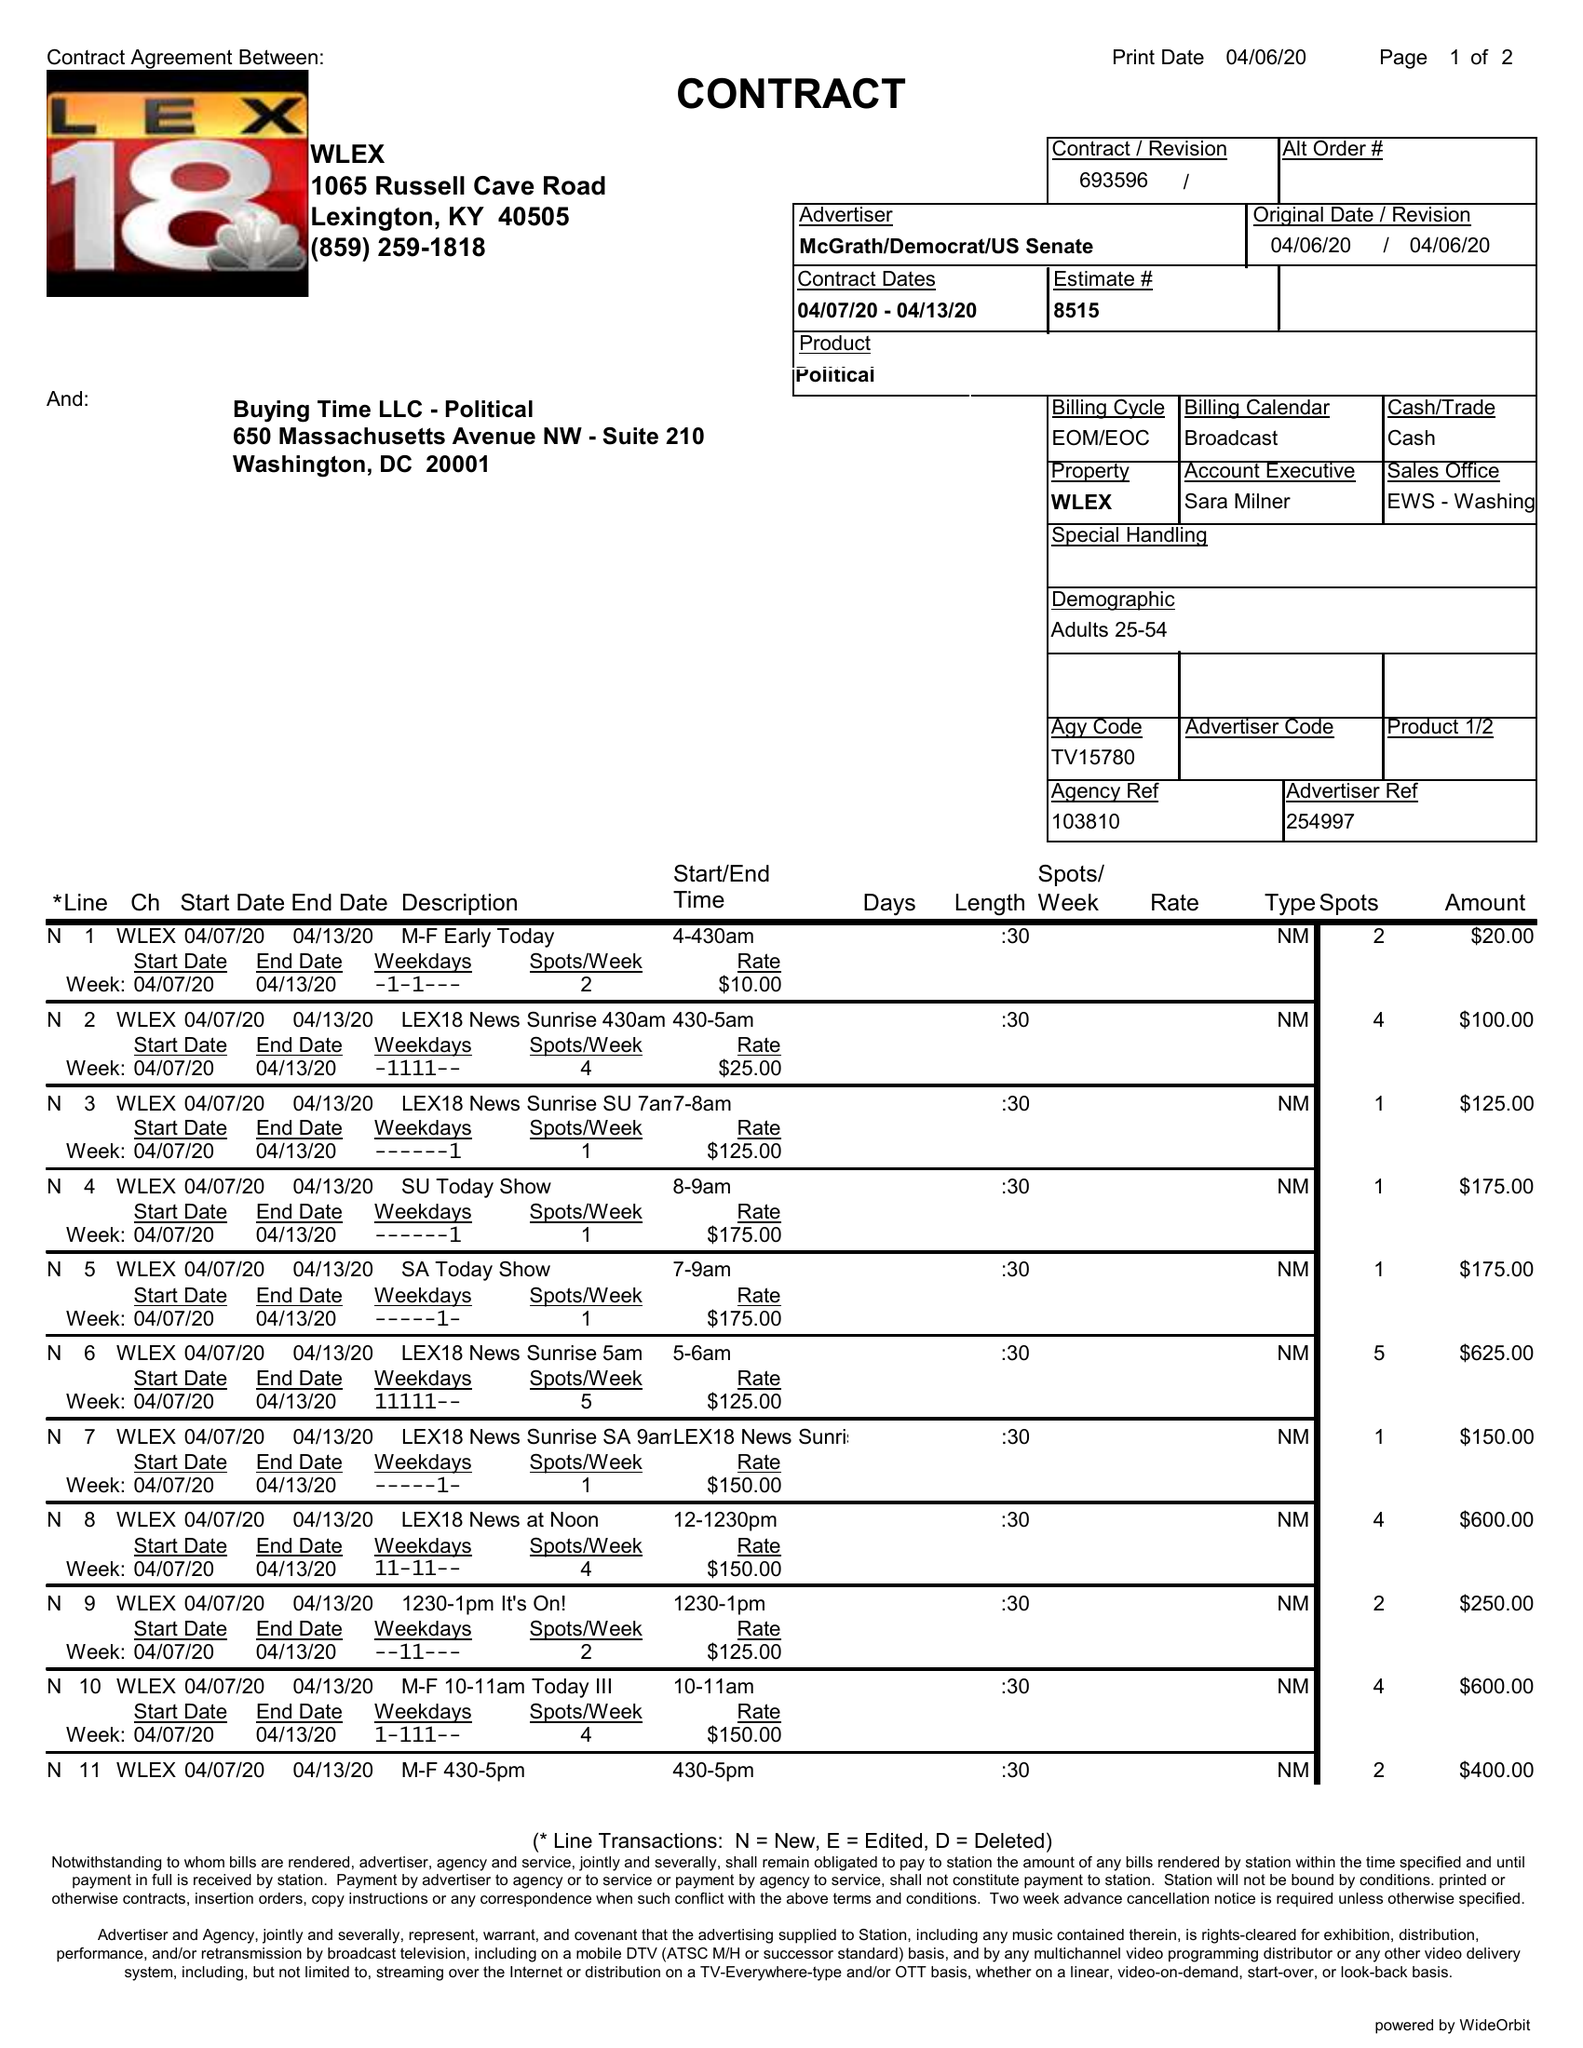What is the value for the advertiser?
Answer the question using a single word or phrase. MCGRATH/DEMOCRAT/USSENATE 